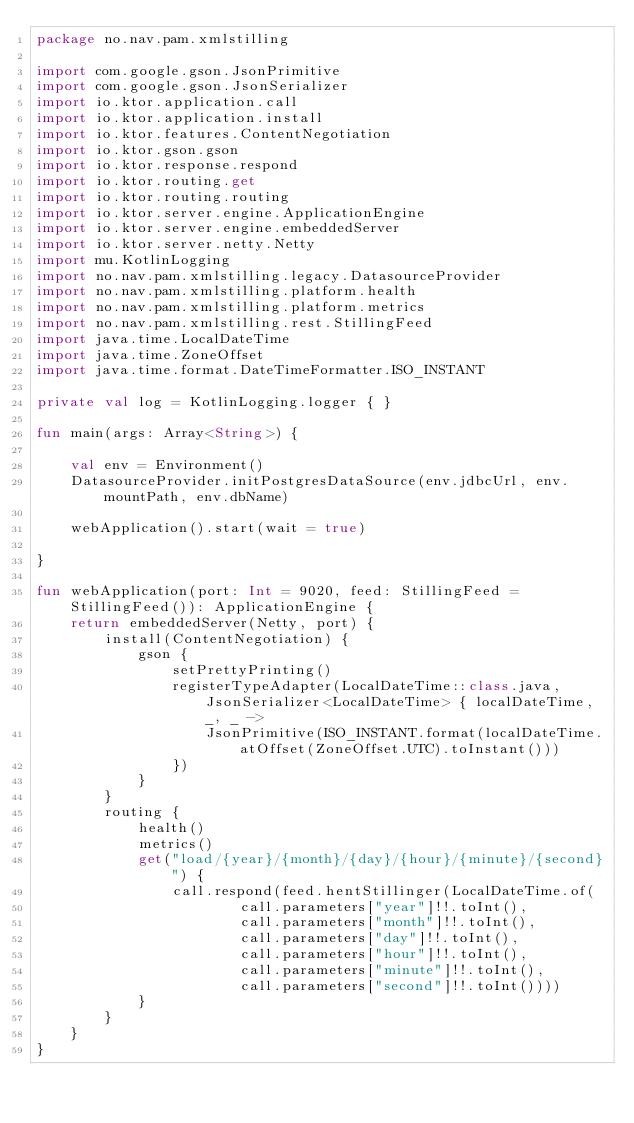<code> <loc_0><loc_0><loc_500><loc_500><_Kotlin_>package no.nav.pam.xmlstilling

import com.google.gson.JsonPrimitive
import com.google.gson.JsonSerializer
import io.ktor.application.call
import io.ktor.application.install
import io.ktor.features.ContentNegotiation
import io.ktor.gson.gson
import io.ktor.response.respond
import io.ktor.routing.get
import io.ktor.routing.routing
import io.ktor.server.engine.ApplicationEngine
import io.ktor.server.engine.embeddedServer
import io.ktor.server.netty.Netty
import mu.KotlinLogging
import no.nav.pam.xmlstilling.legacy.DatasourceProvider
import no.nav.pam.xmlstilling.platform.health
import no.nav.pam.xmlstilling.platform.metrics
import no.nav.pam.xmlstilling.rest.StillingFeed
import java.time.LocalDateTime
import java.time.ZoneOffset
import java.time.format.DateTimeFormatter.ISO_INSTANT

private val log = KotlinLogging.logger { }

fun main(args: Array<String>) {

    val env = Environment()
    DatasourceProvider.initPostgresDataSource(env.jdbcUrl, env.mountPath, env.dbName)

    webApplication().start(wait = true)

}

fun webApplication(port: Int = 9020, feed: StillingFeed = StillingFeed()): ApplicationEngine {
    return embeddedServer(Netty, port) {
        install(ContentNegotiation) {
            gson {
                setPrettyPrinting()
                registerTypeAdapter(LocalDateTime::class.java, JsonSerializer<LocalDateTime> { localDateTime, _, _ ->
                    JsonPrimitive(ISO_INSTANT.format(localDateTime.atOffset(ZoneOffset.UTC).toInstant()))
                })
            }
        }
        routing {
            health()
            metrics()
            get("load/{year}/{month}/{day}/{hour}/{minute}/{second}") {
                call.respond(feed.hentStillinger(LocalDateTime.of(
                        call.parameters["year"]!!.toInt(),
                        call.parameters["month"]!!.toInt(),
                        call.parameters["day"]!!.toInt(),
                        call.parameters["hour"]!!.toInt(),
                        call.parameters["minute"]!!.toInt(),
                        call.parameters["second"]!!.toInt())))
            }
        }
    }
}

</code> 